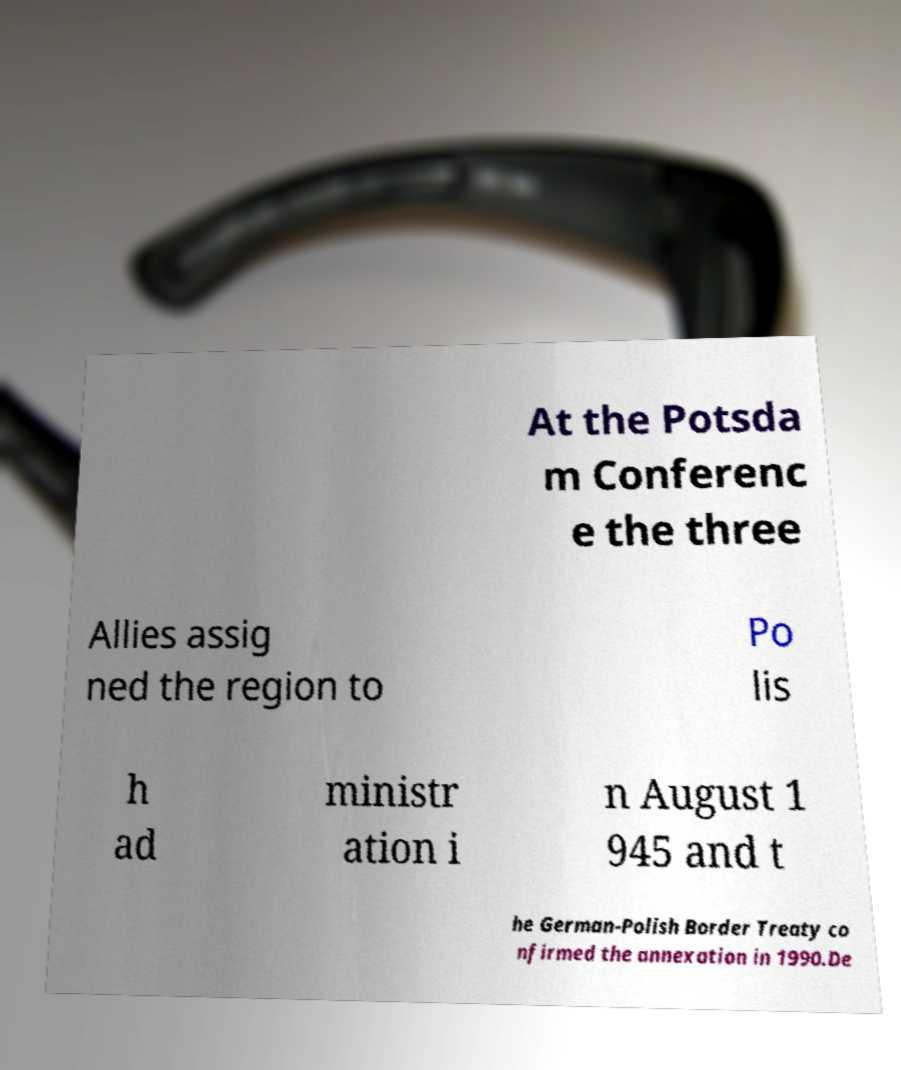For documentation purposes, I need the text within this image transcribed. Could you provide that? At the Potsda m Conferenc e the three Allies assig ned the region to Po lis h ad ministr ation i n August 1 945 and t he German-Polish Border Treaty co nfirmed the annexation in 1990.De 